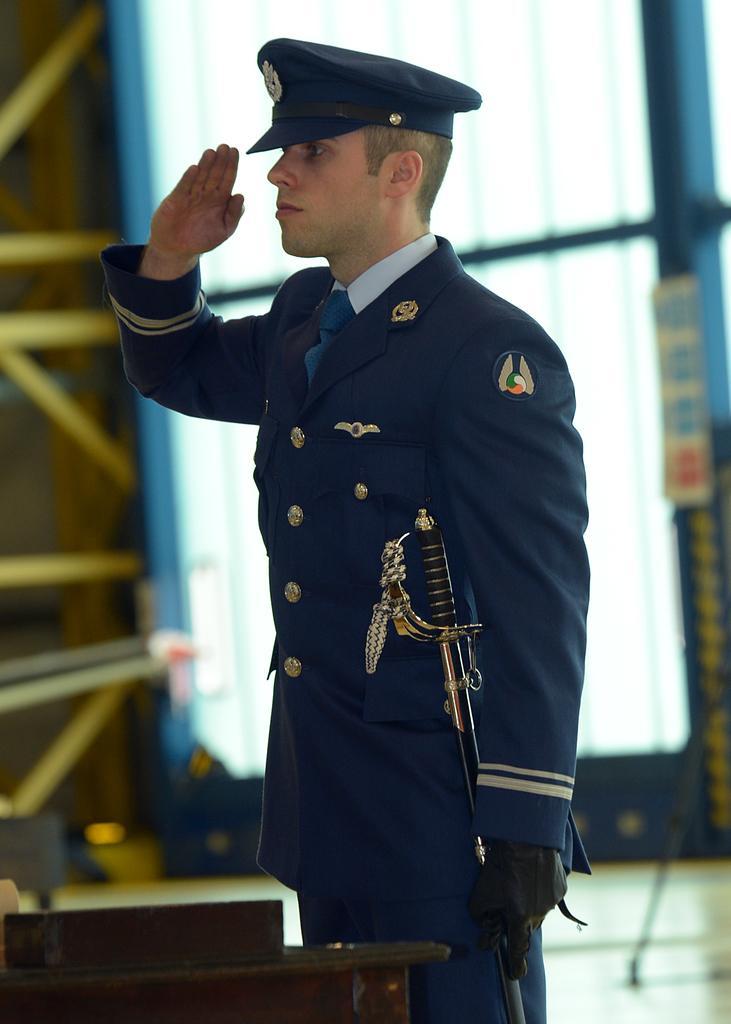In one or two sentences, can you explain what this image depicts? This picture shows man saluting with his hand and we see he wore a cap on his head and a blue coat with a stick on the side 